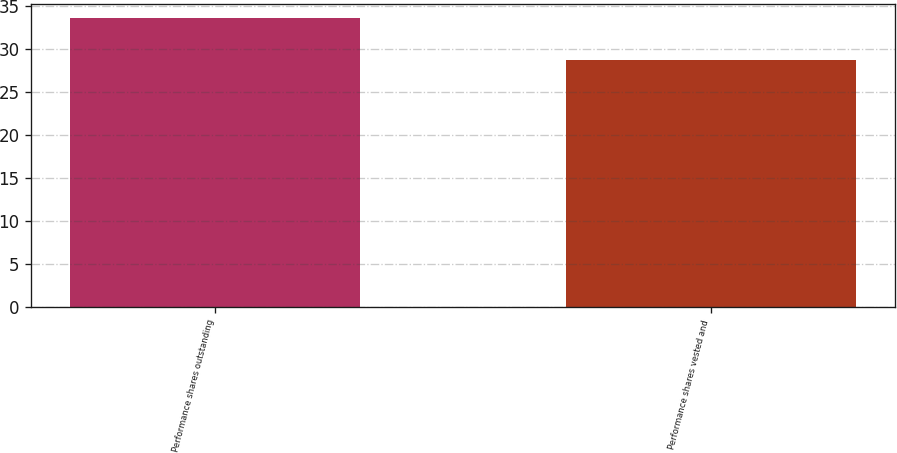<chart> <loc_0><loc_0><loc_500><loc_500><bar_chart><fcel>Performance shares outstanding<fcel>Performance shares vested and<nl><fcel>33.6<fcel>28.8<nl></chart> 